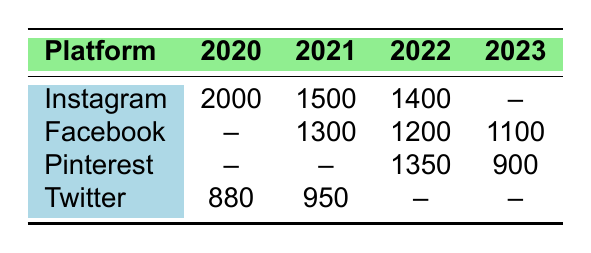What is the highest number of shares recorded for a recipe in 2020? In 2020, only Instagram has recorded shares, which is 2000 for the recipe "Sweet Potato and Black Bean Tacos."
Answer: 2000 Which platform had the most shares for brain-healthy recipes in 2021? In 2021, Instagram had 1500 shares and Facebook had 1300 shares. Therefore, Instagram had the most shares.
Answer: Instagram How many recipes were shared on Pinterest in total from 2020 to 2023? There are no shares recorded for Pinterest in 2020, 2021 has 0, 2022 has 1350, and 2023 has 900. Adding these gives 0 + 0 + 1350 + 900 = 2250.
Answer: 2250 Is there any recipe that had more shares on Facebook than the highest shares on Twitter? The highest share on Twitter is 950 for "Mediterranean Chickpea Salad." Facebook had 1300 shares in 2021 and 1200 in 2022. Both are higher than 950.
Answer: Yes What was the average number of shares across all platforms in 2022? For 2022: Instagram has 1400, Facebook has 1200, Pinterest has 1350, and Twitter has 0. The sum is 1400 + 1200 + 1350 + 0 = 3950. Dividing by 3 (excluding Twitter as it has no data) gives an average of 3950 / 3 = 1316.67.
Answer: 1316.67 Which platform showed a decline in shares from 2021 to 2022? Instagram shares decreased from 1500 in 2021 to 1400 in 2022. Facebook shares also declined from 1300 in 2021 to 1200 in 2022. Both platforms saw a decline.
Answer: Yes How many recipes were shared on Instagram over the years shown? In total, the shares are 2000 (2020) + 1500 (2021) + 1400 (2022) = 4900 for Instagram.
Answer: 4900 In which year did Facebook have the least number of shares for brain-healthy recipes? Facebook had 1300 shares in 2021, 1200 shares in 2022, and no data for 2020. Therefore, 1200 in 2022 is the least.
Answer: 2022 What is the total number of shares for recipes on all platforms in 2023? The shares in 2023 are 900 (Pinterest), 1100 (Facebook), and 1600 (Ginger Turmeric Smoothie). Summing these amounts gives 900 + 1100 + 1600 = 3600.
Answer: 3600 Did the total shares in 2022 exceed those in 2021 for any platform? In 2021: Instagram had 1500, Facebook had 1300, and Twitter had 950. In 2022, Instagram had 1400, Facebook had 1200, and Pinterest had 1350. Total for 2021 is 1500 + 1300 + 950 = 3750. For 2022 it is 1400 + 1200 + 1350 = 3950. Therefore, 2022 exceeded 2021 in total shares.
Answer: Yes 